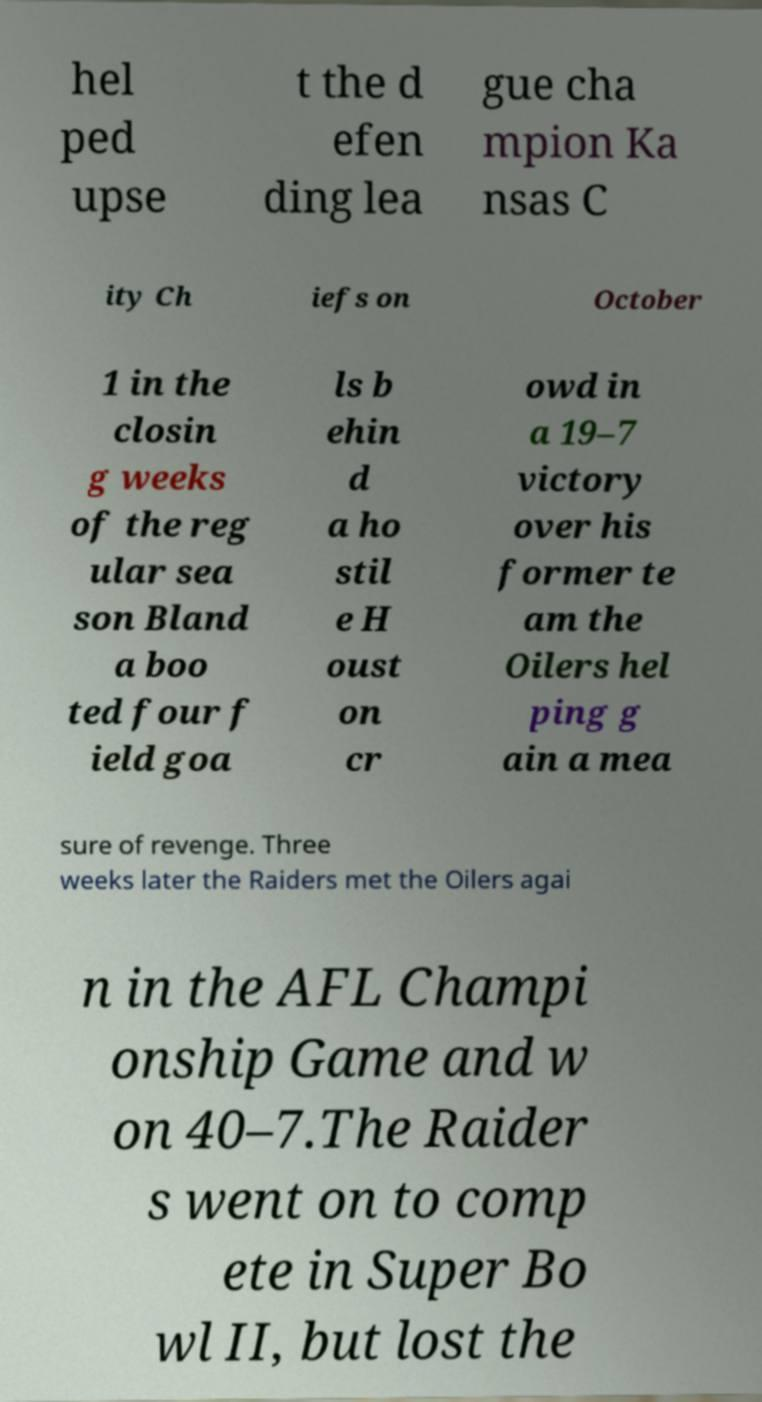There's text embedded in this image that I need extracted. Can you transcribe it verbatim? hel ped upse t the d efen ding lea gue cha mpion Ka nsas C ity Ch iefs on October 1 in the closin g weeks of the reg ular sea son Bland a boo ted four f ield goa ls b ehin d a ho stil e H oust on cr owd in a 19–7 victory over his former te am the Oilers hel ping g ain a mea sure of revenge. Three weeks later the Raiders met the Oilers agai n in the AFL Champi onship Game and w on 40–7.The Raider s went on to comp ete in Super Bo wl II, but lost the 